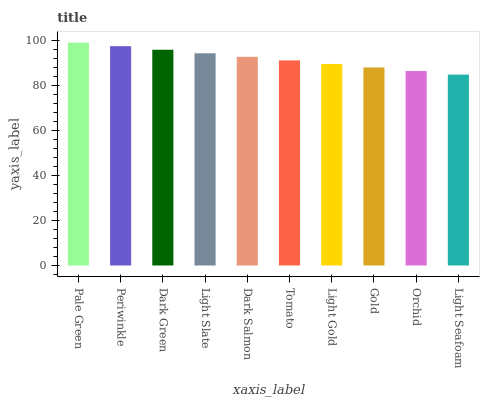Is Periwinkle the minimum?
Answer yes or no. No. Is Periwinkle the maximum?
Answer yes or no. No. Is Pale Green greater than Periwinkle?
Answer yes or no. Yes. Is Periwinkle less than Pale Green?
Answer yes or no. Yes. Is Periwinkle greater than Pale Green?
Answer yes or no. No. Is Pale Green less than Periwinkle?
Answer yes or no. No. Is Dark Salmon the high median?
Answer yes or no. Yes. Is Tomato the low median?
Answer yes or no. Yes. Is Light Slate the high median?
Answer yes or no. No. Is Periwinkle the low median?
Answer yes or no. No. 